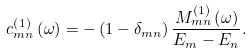Convert formula to latex. <formula><loc_0><loc_0><loc_500><loc_500>c _ { m n } ^ { \left ( 1 \right ) } \left ( \omega \right ) = - \left ( 1 - \delta _ { m n } \right ) \frac { M _ { m n } ^ { \left ( 1 \right ) } \left ( \omega \right ) } { E _ { m } - E _ { n } } .</formula> 